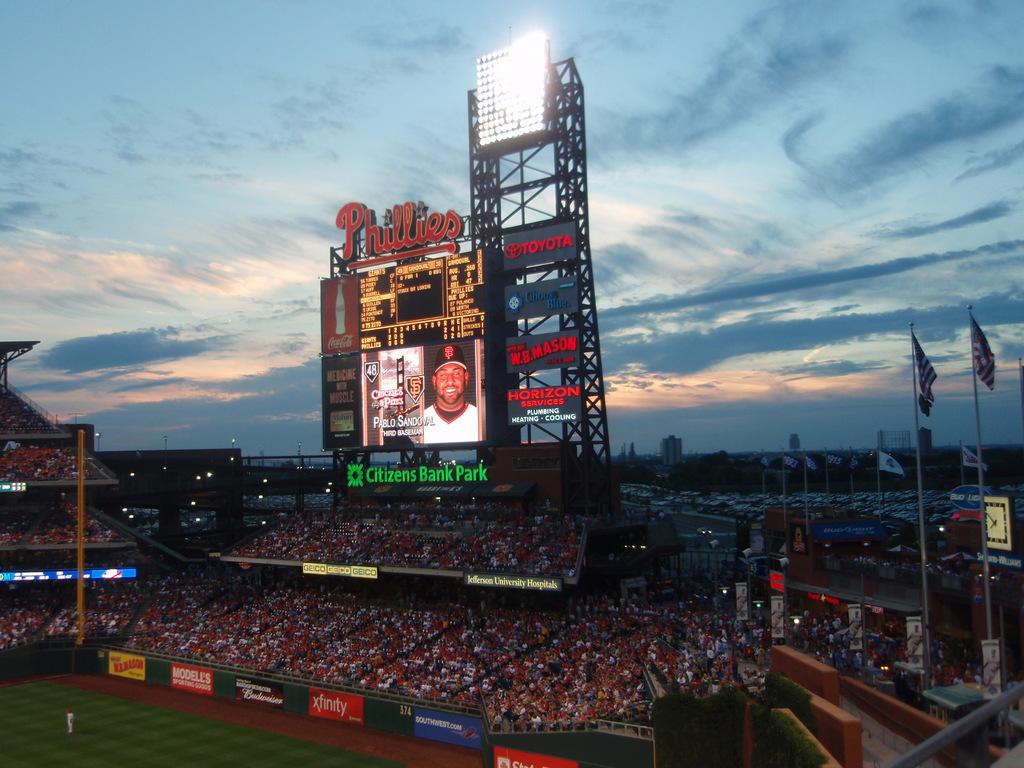What's the name of the baseball park?
Keep it short and to the point. Citizens bank park. 